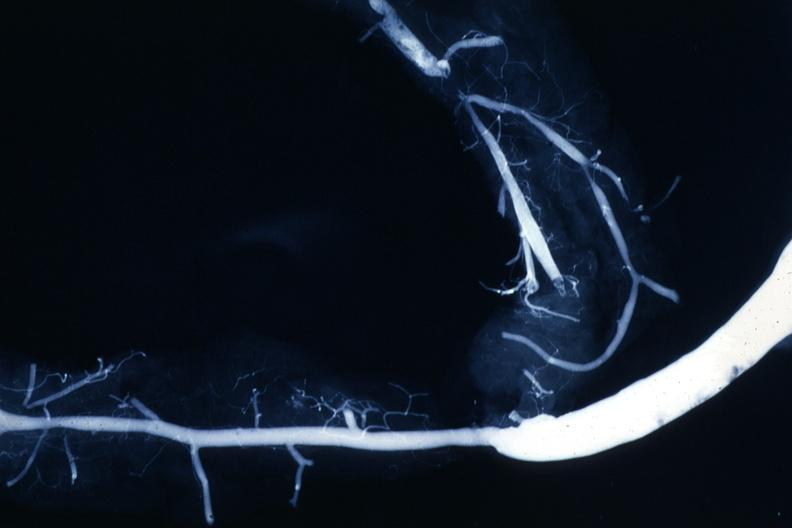does this image show shows rather close-up large vein anastomosing to much smaller artery?
Answer the question using a single word or phrase. Yes 